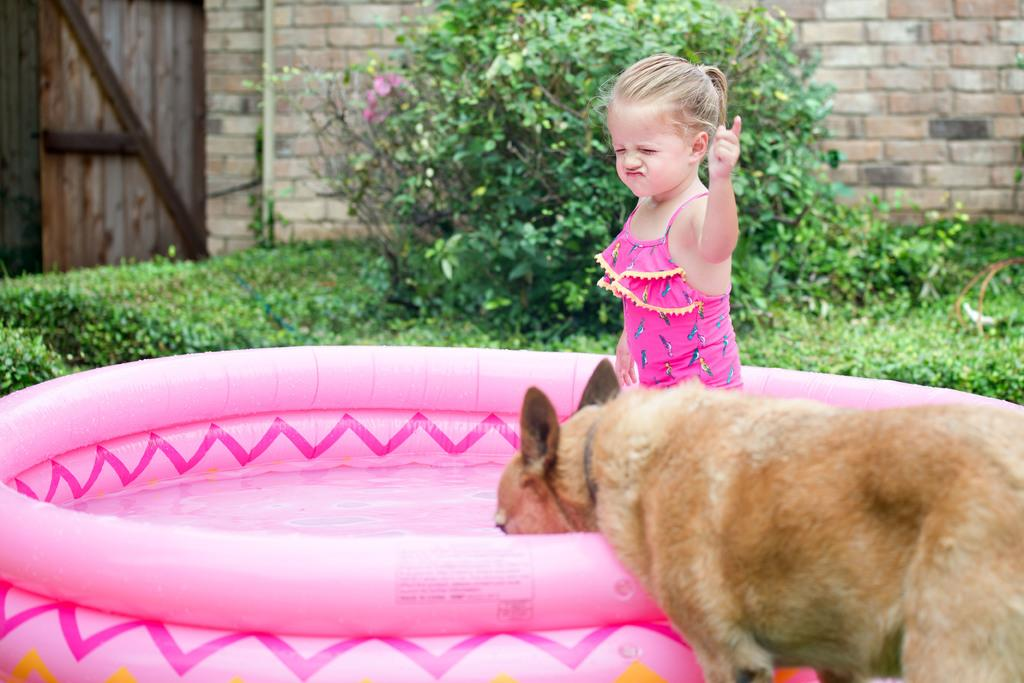What is the main object in the image? There is a water tub in the image. Who or what is present in the image? There is a small girl and a dog in the image. What is the dog doing in the image? The dog is drinking water in the image. Can you describe the dog's position in the image? The dog is standing in the image. What can be seen in the background of the image? The background of the image includes grass, plants, a brick wall, and a wooden door. What type of jam is being spread on the wooden door in the image? There is no jam present in the image, nor is there any indication of spreading jam on the wooden door. 